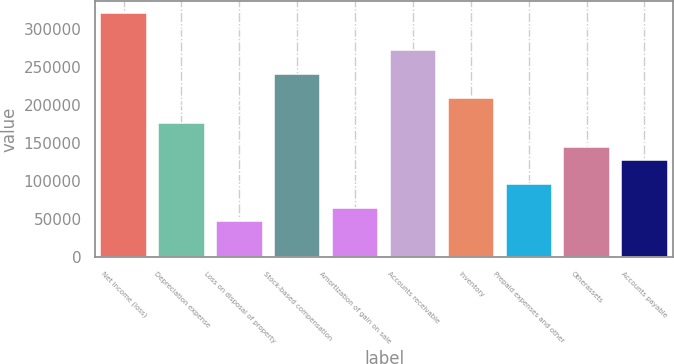<chart> <loc_0><loc_0><loc_500><loc_500><bar_chart><fcel>Net income (loss)<fcel>Depreciation expense<fcel>Loss on disposal of property<fcel>Stock-based compensation<fcel>Amortization of gain on sale<fcel>Accounts receivable<fcel>Inventory<fcel>Prepaid expenses and other<fcel>Otherassets<fcel>Accounts payable<nl><fcel>321467<fcel>176808<fcel>48222.6<fcel>241101<fcel>64295.8<fcel>273247<fcel>208955<fcel>96442.2<fcel>144662<fcel>128589<nl></chart> 